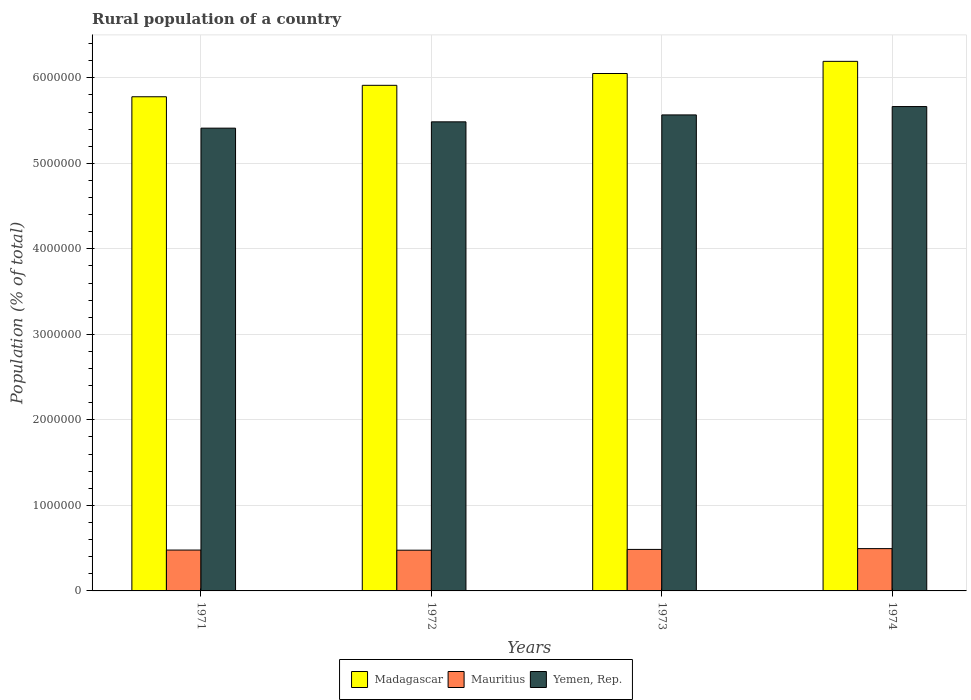How many groups of bars are there?
Provide a short and direct response. 4. How many bars are there on the 4th tick from the right?
Keep it short and to the point. 3. What is the label of the 3rd group of bars from the left?
Your answer should be very brief. 1973. What is the rural population in Yemen, Rep. in 1974?
Offer a very short reply. 5.66e+06. Across all years, what is the maximum rural population in Madagascar?
Provide a short and direct response. 6.19e+06. Across all years, what is the minimum rural population in Mauritius?
Provide a short and direct response. 4.76e+05. In which year was the rural population in Mauritius maximum?
Keep it short and to the point. 1974. What is the total rural population in Yemen, Rep. in the graph?
Keep it short and to the point. 2.21e+07. What is the difference between the rural population in Madagascar in 1972 and that in 1973?
Ensure brevity in your answer.  -1.38e+05. What is the difference between the rural population in Madagascar in 1972 and the rural population in Mauritius in 1971?
Ensure brevity in your answer.  5.43e+06. What is the average rural population in Mauritius per year?
Keep it short and to the point. 4.84e+05. In the year 1973, what is the difference between the rural population in Madagascar and rural population in Mauritius?
Make the answer very short. 5.56e+06. In how many years, is the rural population in Mauritius greater than 3000000 %?
Provide a succinct answer. 0. What is the ratio of the rural population in Madagascar in 1972 to that in 1974?
Your response must be concise. 0.95. Is the rural population in Mauritius in 1971 less than that in 1972?
Your answer should be compact. No. Is the difference between the rural population in Madagascar in 1972 and 1973 greater than the difference between the rural population in Mauritius in 1972 and 1973?
Make the answer very short. No. What is the difference between the highest and the second highest rural population in Mauritius?
Give a very brief answer. 9343. What is the difference between the highest and the lowest rural population in Mauritius?
Offer a terse response. 1.84e+04. What does the 2nd bar from the left in 1974 represents?
Your answer should be very brief. Mauritius. What does the 2nd bar from the right in 1971 represents?
Make the answer very short. Mauritius. Is it the case that in every year, the sum of the rural population in Mauritius and rural population in Yemen, Rep. is greater than the rural population in Madagascar?
Your answer should be compact. No. How many bars are there?
Make the answer very short. 12. How many years are there in the graph?
Offer a terse response. 4. What is the difference between two consecutive major ticks on the Y-axis?
Provide a short and direct response. 1.00e+06. Does the graph contain any zero values?
Your answer should be compact. No. Where does the legend appear in the graph?
Your response must be concise. Bottom center. What is the title of the graph?
Make the answer very short. Rural population of a country. What is the label or title of the Y-axis?
Make the answer very short. Population (% of total). What is the Population (% of total) of Madagascar in 1971?
Keep it short and to the point. 5.78e+06. What is the Population (% of total) in Mauritius in 1971?
Your answer should be compact. 4.78e+05. What is the Population (% of total) in Yemen, Rep. in 1971?
Make the answer very short. 5.41e+06. What is the Population (% of total) of Madagascar in 1972?
Provide a succinct answer. 5.91e+06. What is the Population (% of total) in Mauritius in 1972?
Provide a succinct answer. 4.76e+05. What is the Population (% of total) in Yemen, Rep. in 1972?
Offer a very short reply. 5.49e+06. What is the Population (% of total) in Madagascar in 1973?
Your response must be concise. 6.05e+06. What is the Population (% of total) of Mauritius in 1973?
Offer a terse response. 4.85e+05. What is the Population (% of total) of Yemen, Rep. in 1973?
Offer a very short reply. 5.57e+06. What is the Population (% of total) of Madagascar in 1974?
Offer a terse response. 6.19e+06. What is the Population (% of total) in Mauritius in 1974?
Your answer should be compact. 4.95e+05. What is the Population (% of total) of Yemen, Rep. in 1974?
Give a very brief answer. 5.66e+06. Across all years, what is the maximum Population (% of total) of Madagascar?
Keep it short and to the point. 6.19e+06. Across all years, what is the maximum Population (% of total) in Mauritius?
Offer a very short reply. 4.95e+05. Across all years, what is the maximum Population (% of total) of Yemen, Rep.?
Give a very brief answer. 5.66e+06. Across all years, what is the minimum Population (% of total) in Madagascar?
Keep it short and to the point. 5.78e+06. Across all years, what is the minimum Population (% of total) in Mauritius?
Give a very brief answer. 4.76e+05. Across all years, what is the minimum Population (% of total) in Yemen, Rep.?
Offer a terse response. 5.41e+06. What is the total Population (% of total) in Madagascar in the graph?
Keep it short and to the point. 2.39e+07. What is the total Population (% of total) in Mauritius in the graph?
Your answer should be very brief. 1.93e+06. What is the total Population (% of total) of Yemen, Rep. in the graph?
Provide a short and direct response. 2.21e+07. What is the difference between the Population (% of total) in Madagascar in 1971 and that in 1972?
Offer a very short reply. -1.34e+05. What is the difference between the Population (% of total) in Mauritius in 1971 and that in 1972?
Offer a very short reply. 1543. What is the difference between the Population (% of total) in Yemen, Rep. in 1971 and that in 1972?
Provide a succinct answer. -7.37e+04. What is the difference between the Population (% of total) of Madagascar in 1971 and that in 1973?
Offer a terse response. -2.72e+05. What is the difference between the Population (% of total) in Mauritius in 1971 and that in 1973?
Make the answer very short. -7487. What is the difference between the Population (% of total) of Yemen, Rep. in 1971 and that in 1973?
Give a very brief answer. -1.55e+05. What is the difference between the Population (% of total) in Madagascar in 1971 and that in 1974?
Your answer should be compact. -4.14e+05. What is the difference between the Population (% of total) of Mauritius in 1971 and that in 1974?
Ensure brevity in your answer.  -1.68e+04. What is the difference between the Population (% of total) in Yemen, Rep. in 1971 and that in 1974?
Offer a terse response. -2.53e+05. What is the difference between the Population (% of total) in Madagascar in 1972 and that in 1973?
Provide a short and direct response. -1.38e+05. What is the difference between the Population (% of total) of Mauritius in 1972 and that in 1973?
Offer a terse response. -9030. What is the difference between the Population (% of total) of Yemen, Rep. in 1972 and that in 1973?
Your answer should be compact. -8.10e+04. What is the difference between the Population (% of total) in Madagascar in 1972 and that in 1974?
Your answer should be very brief. -2.80e+05. What is the difference between the Population (% of total) of Mauritius in 1972 and that in 1974?
Your answer should be very brief. -1.84e+04. What is the difference between the Population (% of total) of Yemen, Rep. in 1972 and that in 1974?
Make the answer very short. -1.79e+05. What is the difference between the Population (% of total) of Madagascar in 1973 and that in 1974?
Offer a very short reply. -1.42e+05. What is the difference between the Population (% of total) of Mauritius in 1973 and that in 1974?
Offer a terse response. -9343. What is the difference between the Population (% of total) in Yemen, Rep. in 1973 and that in 1974?
Provide a short and direct response. -9.78e+04. What is the difference between the Population (% of total) of Madagascar in 1971 and the Population (% of total) of Mauritius in 1972?
Provide a short and direct response. 5.30e+06. What is the difference between the Population (% of total) in Madagascar in 1971 and the Population (% of total) in Yemen, Rep. in 1972?
Your answer should be compact. 2.93e+05. What is the difference between the Population (% of total) in Mauritius in 1971 and the Population (% of total) in Yemen, Rep. in 1972?
Provide a succinct answer. -5.01e+06. What is the difference between the Population (% of total) in Madagascar in 1971 and the Population (% of total) in Mauritius in 1973?
Your answer should be very brief. 5.29e+06. What is the difference between the Population (% of total) of Madagascar in 1971 and the Population (% of total) of Yemen, Rep. in 1973?
Ensure brevity in your answer.  2.12e+05. What is the difference between the Population (% of total) of Mauritius in 1971 and the Population (% of total) of Yemen, Rep. in 1973?
Give a very brief answer. -5.09e+06. What is the difference between the Population (% of total) in Madagascar in 1971 and the Population (% of total) in Mauritius in 1974?
Keep it short and to the point. 5.28e+06. What is the difference between the Population (% of total) of Madagascar in 1971 and the Population (% of total) of Yemen, Rep. in 1974?
Provide a short and direct response. 1.15e+05. What is the difference between the Population (% of total) of Mauritius in 1971 and the Population (% of total) of Yemen, Rep. in 1974?
Make the answer very short. -5.19e+06. What is the difference between the Population (% of total) in Madagascar in 1972 and the Population (% of total) in Mauritius in 1973?
Keep it short and to the point. 5.43e+06. What is the difference between the Population (% of total) in Madagascar in 1972 and the Population (% of total) in Yemen, Rep. in 1973?
Provide a short and direct response. 3.46e+05. What is the difference between the Population (% of total) in Mauritius in 1972 and the Population (% of total) in Yemen, Rep. in 1973?
Provide a short and direct response. -5.09e+06. What is the difference between the Population (% of total) of Madagascar in 1972 and the Population (% of total) of Mauritius in 1974?
Make the answer very short. 5.42e+06. What is the difference between the Population (% of total) in Madagascar in 1972 and the Population (% of total) in Yemen, Rep. in 1974?
Provide a short and direct response. 2.48e+05. What is the difference between the Population (% of total) in Mauritius in 1972 and the Population (% of total) in Yemen, Rep. in 1974?
Keep it short and to the point. -5.19e+06. What is the difference between the Population (% of total) in Madagascar in 1973 and the Population (% of total) in Mauritius in 1974?
Keep it short and to the point. 5.56e+06. What is the difference between the Population (% of total) in Madagascar in 1973 and the Population (% of total) in Yemen, Rep. in 1974?
Your response must be concise. 3.86e+05. What is the difference between the Population (% of total) in Mauritius in 1973 and the Population (% of total) in Yemen, Rep. in 1974?
Keep it short and to the point. -5.18e+06. What is the average Population (% of total) of Madagascar per year?
Your answer should be compact. 5.98e+06. What is the average Population (% of total) in Mauritius per year?
Make the answer very short. 4.84e+05. What is the average Population (% of total) in Yemen, Rep. per year?
Your answer should be compact. 5.53e+06. In the year 1971, what is the difference between the Population (% of total) of Madagascar and Population (% of total) of Mauritius?
Provide a succinct answer. 5.30e+06. In the year 1971, what is the difference between the Population (% of total) of Madagascar and Population (% of total) of Yemen, Rep.?
Provide a succinct answer. 3.67e+05. In the year 1971, what is the difference between the Population (% of total) of Mauritius and Population (% of total) of Yemen, Rep.?
Ensure brevity in your answer.  -4.93e+06. In the year 1972, what is the difference between the Population (% of total) in Madagascar and Population (% of total) in Mauritius?
Offer a terse response. 5.44e+06. In the year 1972, what is the difference between the Population (% of total) in Madagascar and Population (% of total) in Yemen, Rep.?
Your response must be concise. 4.27e+05. In the year 1972, what is the difference between the Population (% of total) of Mauritius and Population (% of total) of Yemen, Rep.?
Provide a succinct answer. -5.01e+06. In the year 1973, what is the difference between the Population (% of total) of Madagascar and Population (% of total) of Mauritius?
Offer a terse response. 5.56e+06. In the year 1973, what is the difference between the Population (% of total) in Madagascar and Population (% of total) in Yemen, Rep.?
Give a very brief answer. 4.84e+05. In the year 1973, what is the difference between the Population (% of total) in Mauritius and Population (% of total) in Yemen, Rep.?
Give a very brief answer. -5.08e+06. In the year 1974, what is the difference between the Population (% of total) in Madagascar and Population (% of total) in Mauritius?
Provide a succinct answer. 5.70e+06. In the year 1974, what is the difference between the Population (% of total) in Madagascar and Population (% of total) in Yemen, Rep.?
Your answer should be compact. 5.28e+05. In the year 1974, what is the difference between the Population (% of total) of Mauritius and Population (% of total) of Yemen, Rep.?
Give a very brief answer. -5.17e+06. What is the ratio of the Population (% of total) in Madagascar in 1971 to that in 1972?
Your answer should be compact. 0.98. What is the ratio of the Population (% of total) in Yemen, Rep. in 1971 to that in 1972?
Provide a short and direct response. 0.99. What is the ratio of the Population (% of total) of Madagascar in 1971 to that in 1973?
Provide a succinct answer. 0.96. What is the ratio of the Population (% of total) in Mauritius in 1971 to that in 1973?
Your answer should be very brief. 0.98. What is the ratio of the Population (% of total) of Yemen, Rep. in 1971 to that in 1973?
Provide a succinct answer. 0.97. What is the ratio of the Population (% of total) of Madagascar in 1971 to that in 1974?
Offer a very short reply. 0.93. What is the ratio of the Population (% of total) in Mauritius in 1971 to that in 1974?
Provide a short and direct response. 0.97. What is the ratio of the Population (% of total) in Yemen, Rep. in 1971 to that in 1974?
Offer a terse response. 0.96. What is the ratio of the Population (% of total) in Madagascar in 1972 to that in 1973?
Ensure brevity in your answer.  0.98. What is the ratio of the Population (% of total) of Mauritius in 1972 to that in 1973?
Make the answer very short. 0.98. What is the ratio of the Population (% of total) of Yemen, Rep. in 1972 to that in 1973?
Your answer should be very brief. 0.99. What is the ratio of the Population (% of total) in Madagascar in 1972 to that in 1974?
Your answer should be compact. 0.95. What is the ratio of the Population (% of total) of Mauritius in 1972 to that in 1974?
Make the answer very short. 0.96. What is the ratio of the Population (% of total) in Yemen, Rep. in 1972 to that in 1974?
Your answer should be compact. 0.97. What is the ratio of the Population (% of total) of Mauritius in 1973 to that in 1974?
Offer a very short reply. 0.98. What is the ratio of the Population (% of total) in Yemen, Rep. in 1973 to that in 1974?
Your answer should be very brief. 0.98. What is the difference between the highest and the second highest Population (% of total) of Madagascar?
Provide a short and direct response. 1.42e+05. What is the difference between the highest and the second highest Population (% of total) of Mauritius?
Offer a terse response. 9343. What is the difference between the highest and the second highest Population (% of total) of Yemen, Rep.?
Your response must be concise. 9.78e+04. What is the difference between the highest and the lowest Population (% of total) in Madagascar?
Provide a short and direct response. 4.14e+05. What is the difference between the highest and the lowest Population (% of total) of Mauritius?
Provide a succinct answer. 1.84e+04. What is the difference between the highest and the lowest Population (% of total) of Yemen, Rep.?
Offer a terse response. 2.53e+05. 